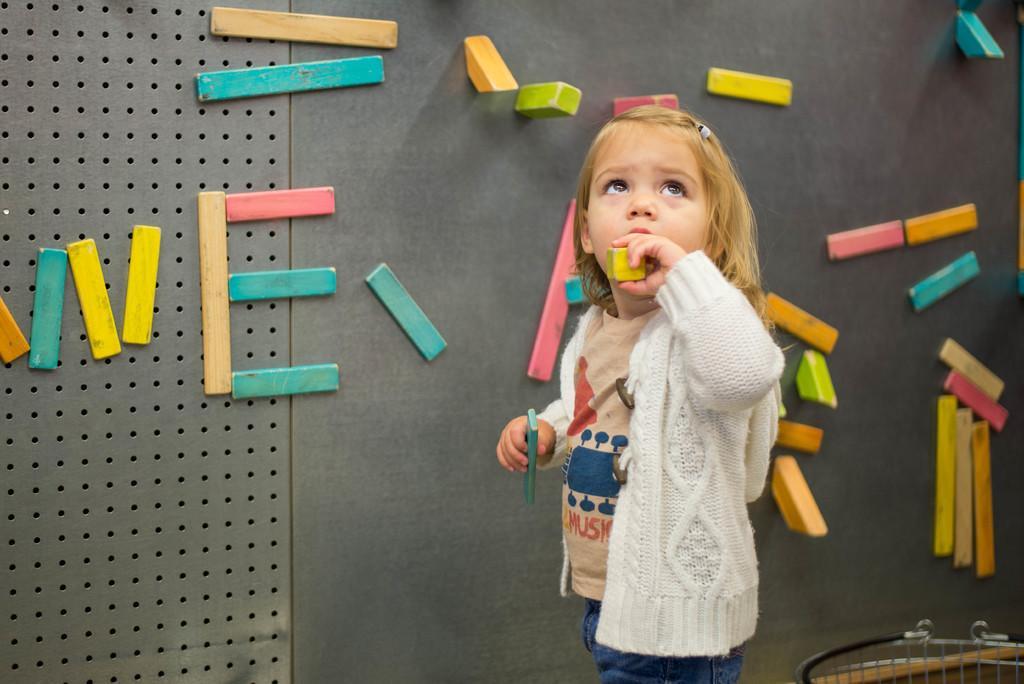How would you summarize this image in a sentence or two? In this image there is a girl standing. She is holding two objects in her hands. Behind her there is a wall. There are wooden blocks stacked on the wall. 